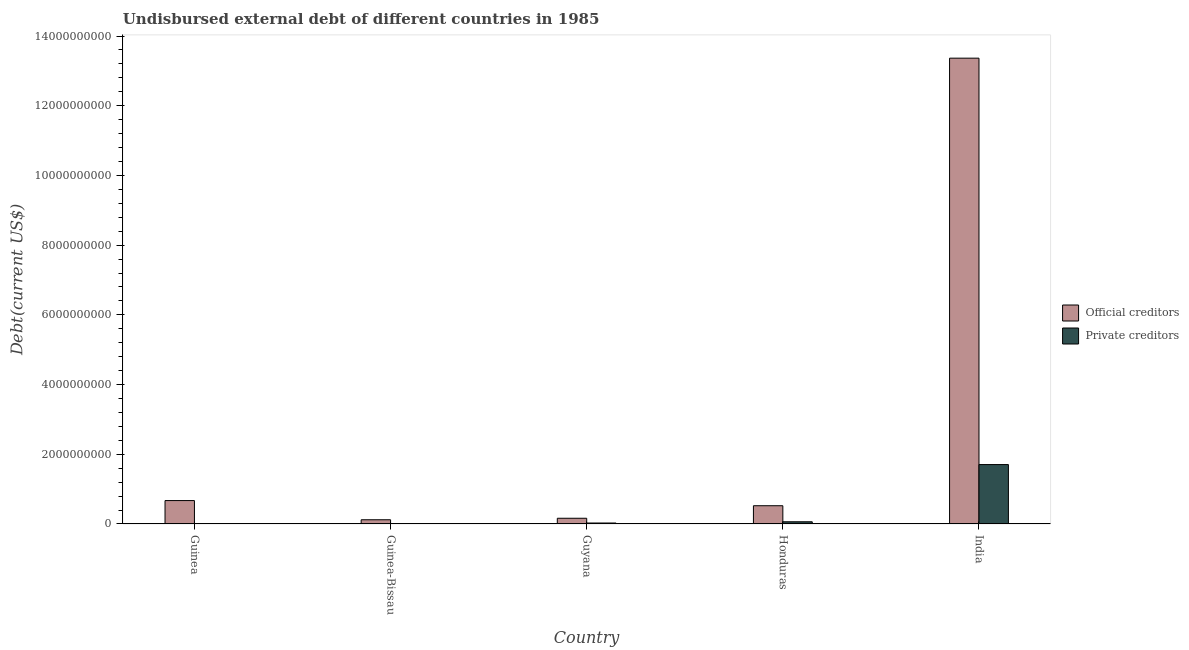How many different coloured bars are there?
Ensure brevity in your answer.  2. How many bars are there on the 2nd tick from the left?
Give a very brief answer. 2. How many bars are there on the 4th tick from the right?
Provide a succinct answer. 2. What is the label of the 5th group of bars from the left?
Give a very brief answer. India. What is the undisbursed external debt of official creditors in India?
Ensure brevity in your answer.  1.34e+1. Across all countries, what is the maximum undisbursed external debt of private creditors?
Offer a terse response. 1.70e+09. Across all countries, what is the minimum undisbursed external debt of private creditors?
Ensure brevity in your answer.  3.49e+06. In which country was the undisbursed external debt of official creditors minimum?
Your response must be concise. Guinea-Bissau. What is the total undisbursed external debt of official creditors in the graph?
Offer a very short reply. 1.48e+1. What is the difference between the undisbursed external debt of official creditors in Guinea and that in India?
Provide a short and direct response. -1.27e+1. What is the difference between the undisbursed external debt of official creditors in Guinea-Bissau and the undisbursed external debt of private creditors in India?
Ensure brevity in your answer.  -1.58e+09. What is the average undisbursed external debt of official creditors per country?
Your answer should be very brief. 2.97e+09. What is the difference between the undisbursed external debt of private creditors and undisbursed external debt of official creditors in Guyana?
Your response must be concise. -1.36e+08. What is the ratio of the undisbursed external debt of private creditors in Guinea to that in Guyana?
Ensure brevity in your answer.  0.13. Is the difference between the undisbursed external debt of private creditors in Guinea and India greater than the difference between the undisbursed external debt of official creditors in Guinea and India?
Provide a succinct answer. Yes. What is the difference between the highest and the second highest undisbursed external debt of private creditors?
Your answer should be very brief. 1.64e+09. What is the difference between the highest and the lowest undisbursed external debt of official creditors?
Your answer should be compact. 1.32e+1. In how many countries, is the undisbursed external debt of official creditors greater than the average undisbursed external debt of official creditors taken over all countries?
Ensure brevity in your answer.  1. Is the sum of the undisbursed external debt of private creditors in Guinea and India greater than the maximum undisbursed external debt of official creditors across all countries?
Give a very brief answer. No. What does the 1st bar from the left in Guinea represents?
Make the answer very short. Official creditors. What does the 2nd bar from the right in India represents?
Make the answer very short. Official creditors. Are all the bars in the graph horizontal?
Your answer should be compact. No. How many countries are there in the graph?
Provide a short and direct response. 5. What is the difference between two consecutive major ticks on the Y-axis?
Provide a short and direct response. 2.00e+09. Does the graph contain grids?
Your response must be concise. No. Where does the legend appear in the graph?
Provide a short and direct response. Center right. How are the legend labels stacked?
Make the answer very short. Vertical. What is the title of the graph?
Your response must be concise. Undisbursed external debt of different countries in 1985. Does "Domestic liabilities" appear as one of the legend labels in the graph?
Your response must be concise. No. What is the label or title of the X-axis?
Make the answer very short. Country. What is the label or title of the Y-axis?
Provide a short and direct response. Debt(current US$). What is the Debt(current US$) of Official creditors in Guinea?
Provide a succinct answer. 6.72e+08. What is the Debt(current US$) of Private creditors in Guinea?
Give a very brief answer. 3.49e+06. What is the Debt(current US$) in Official creditors in Guinea-Bissau?
Provide a succinct answer. 1.21e+08. What is the Debt(current US$) in Private creditors in Guinea-Bissau?
Give a very brief answer. 7.95e+06. What is the Debt(current US$) in Official creditors in Guyana?
Make the answer very short. 1.64e+08. What is the Debt(current US$) of Private creditors in Guyana?
Offer a terse response. 2.79e+07. What is the Debt(current US$) in Official creditors in Honduras?
Keep it short and to the point. 5.24e+08. What is the Debt(current US$) in Private creditors in Honduras?
Offer a very short reply. 6.33e+07. What is the Debt(current US$) in Official creditors in India?
Your response must be concise. 1.34e+1. What is the Debt(current US$) of Private creditors in India?
Offer a very short reply. 1.70e+09. Across all countries, what is the maximum Debt(current US$) in Official creditors?
Your answer should be compact. 1.34e+1. Across all countries, what is the maximum Debt(current US$) of Private creditors?
Your response must be concise. 1.70e+09. Across all countries, what is the minimum Debt(current US$) in Official creditors?
Make the answer very short. 1.21e+08. Across all countries, what is the minimum Debt(current US$) in Private creditors?
Your answer should be very brief. 3.49e+06. What is the total Debt(current US$) of Official creditors in the graph?
Your answer should be very brief. 1.48e+1. What is the total Debt(current US$) of Private creditors in the graph?
Give a very brief answer. 1.81e+09. What is the difference between the Debt(current US$) in Official creditors in Guinea and that in Guinea-Bissau?
Your response must be concise. 5.51e+08. What is the difference between the Debt(current US$) in Private creditors in Guinea and that in Guinea-Bissau?
Keep it short and to the point. -4.47e+06. What is the difference between the Debt(current US$) in Official creditors in Guinea and that in Guyana?
Offer a very short reply. 5.08e+08. What is the difference between the Debt(current US$) in Private creditors in Guinea and that in Guyana?
Provide a succinct answer. -2.44e+07. What is the difference between the Debt(current US$) of Official creditors in Guinea and that in Honduras?
Provide a succinct answer. 1.48e+08. What is the difference between the Debt(current US$) of Private creditors in Guinea and that in Honduras?
Provide a succinct answer. -5.99e+07. What is the difference between the Debt(current US$) of Official creditors in Guinea and that in India?
Provide a succinct answer. -1.27e+1. What is the difference between the Debt(current US$) in Private creditors in Guinea and that in India?
Your response must be concise. -1.70e+09. What is the difference between the Debt(current US$) of Official creditors in Guinea-Bissau and that in Guyana?
Offer a terse response. -4.32e+07. What is the difference between the Debt(current US$) of Private creditors in Guinea-Bissau and that in Guyana?
Provide a succinct answer. -1.99e+07. What is the difference between the Debt(current US$) of Official creditors in Guinea-Bissau and that in Honduras?
Give a very brief answer. -4.03e+08. What is the difference between the Debt(current US$) in Private creditors in Guinea-Bissau and that in Honduras?
Offer a terse response. -5.54e+07. What is the difference between the Debt(current US$) in Official creditors in Guinea-Bissau and that in India?
Give a very brief answer. -1.32e+1. What is the difference between the Debt(current US$) of Private creditors in Guinea-Bissau and that in India?
Your answer should be very brief. -1.70e+09. What is the difference between the Debt(current US$) in Official creditors in Guyana and that in Honduras?
Give a very brief answer. -3.59e+08. What is the difference between the Debt(current US$) of Private creditors in Guyana and that in Honduras?
Offer a terse response. -3.55e+07. What is the difference between the Debt(current US$) of Official creditors in Guyana and that in India?
Keep it short and to the point. -1.32e+1. What is the difference between the Debt(current US$) in Private creditors in Guyana and that in India?
Your answer should be very brief. -1.68e+09. What is the difference between the Debt(current US$) in Official creditors in Honduras and that in India?
Your response must be concise. -1.28e+1. What is the difference between the Debt(current US$) of Private creditors in Honduras and that in India?
Ensure brevity in your answer.  -1.64e+09. What is the difference between the Debt(current US$) of Official creditors in Guinea and the Debt(current US$) of Private creditors in Guinea-Bissau?
Your answer should be compact. 6.64e+08. What is the difference between the Debt(current US$) in Official creditors in Guinea and the Debt(current US$) in Private creditors in Guyana?
Your answer should be compact. 6.44e+08. What is the difference between the Debt(current US$) of Official creditors in Guinea and the Debt(current US$) of Private creditors in Honduras?
Offer a terse response. 6.08e+08. What is the difference between the Debt(current US$) of Official creditors in Guinea and the Debt(current US$) of Private creditors in India?
Give a very brief answer. -1.03e+09. What is the difference between the Debt(current US$) of Official creditors in Guinea-Bissau and the Debt(current US$) of Private creditors in Guyana?
Your answer should be compact. 9.31e+07. What is the difference between the Debt(current US$) of Official creditors in Guinea-Bissau and the Debt(current US$) of Private creditors in Honduras?
Make the answer very short. 5.76e+07. What is the difference between the Debt(current US$) in Official creditors in Guinea-Bissau and the Debt(current US$) in Private creditors in India?
Make the answer very short. -1.58e+09. What is the difference between the Debt(current US$) in Official creditors in Guyana and the Debt(current US$) in Private creditors in Honduras?
Give a very brief answer. 1.01e+08. What is the difference between the Debt(current US$) of Official creditors in Guyana and the Debt(current US$) of Private creditors in India?
Provide a succinct answer. -1.54e+09. What is the difference between the Debt(current US$) in Official creditors in Honduras and the Debt(current US$) in Private creditors in India?
Ensure brevity in your answer.  -1.18e+09. What is the average Debt(current US$) in Official creditors per country?
Your answer should be very brief. 2.97e+09. What is the average Debt(current US$) of Private creditors per country?
Keep it short and to the point. 3.61e+08. What is the difference between the Debt(current US$) in Official creditors and Debt(current US$) in Private creditors in Guinea?
Provide a short and direct response. 6.68e+08. What is the difference between the Debt(current US$) of Official creditors and Debt(current US$) of Private creditors in Guinea-Bissau?
Offer a very short reply. 1.13e+08. What is the difference between the Debt(current US$) of Official creditors and Debt(current US$) of Private creditors in Guyana?
Provide a short and direct response. 1.36e+08. What is the difference between the Debt(current US$) of Official creditors and Debt(current US$) of Private creditors in Honduras?
Offer a very short reply. 4.60e+08. What is the difference between the Debt(current US$) in Official creditors and Debt(current US$) in Private creditors in India?
Provide a short and direct response. 1.17e+1. What is the ratio of the Debt(current US$) of Official creditors in Guinea to that in Guinea-Bissau?
Give a very brief answer. 5.55. What is the ratio of the Debt(current US$) in Private creditors in Guinea to that in Guinea-Bissau?
Your answer should be compact. 0.44. What is the ratio of the Debt(current US$) in Official creditors in Guinea to that in Guyana?
Your response must be concise. 4.09. What is the ratio of the Debt(current US$) of Private creditors in Guinea to that in Guyana?
Ensure brevity in your answer.  0.13. What is the ratio of the Debt(current US$) in Official creditors in Guinea to that in Honduras?
Offer a very short reply. 1.28. What is the ratio of the Debt(current US$) of Private creditors in Guinea to that in Honduras?
Ensure brevity in your answer.  0.06. What is the ratio of the Debt(current US$) of Official creditors in Guinea to that in India?
Provide a short and direct response. 0.05. What is the ratio of the Debt(current US$) in Private creditors in Guinea to that in India?
Offer a terse response. 0. What is the ratio of the Debt(current US$) in Official creditors in Guinea-Bissau to that in Guyana?
Give a very brief answer. 0.74. What is the ratio of the Debt(current US$) of Private creditors in Guinea-Bissau to that in Guyana?
Give a very brief answer. 0.29. What is the ratio of the Debt(current US$) of Official creditors in Guinea-Bissau to that in Honduras?
Offer a terse response. 0.23. What is the ratio of the Debt(current US$) in Private creditors in Guinea-Bissau to that in Honduras?
Offer a very short reply. 0.13. What is the ratio of the Debt(current US$) of Official creditors in Guinea-Bissau to that in India?
Provide a succinct answer. 0.01. What is the ratio of the Debt(current US$) in Private creditors in Guinea-Bissau to that in India?
Your answer should be very brief. 0. What is the ratio of the Debt(current US$) in Official creditors in Guyana to that in Honduras?
Your response must be concise. 0.31. What is the ratio of the Debt(current US$) in Private creditors in Guyana to that in Honduras?
Offer a terse response. 0.44. What is the ratio of the Debt(current US$) in Official creditors in Guyana to that in India?
Provide a short and direct response. 0.01. What is the ratio of the Debt(current US$) in Private creditors in Guyana to that in India?
Provide a succinct answer. 0.02. What is the ratio of the Debt(current US$) in Official creditors in Honduras to that in India?
Provide a short and direct response. 0.04. What is the ratio of the Debt(current US$) of Private creditors in Honduras to that in India?
Give a very brief answer. 0.04. What is the difference between the highest and the second highest Debt(current US$) in Official creditors?
Your response must be concise. 1.27e+1. What is the difference between the highest and the second highest Debt(current US$) in Private creditors?
Offer a terse response. 1.64e+09. What is the difference between the highest and the lowest Debt(current US$) in Official creditors?
Provide a succinct answer. 1.32e+1. What is the difference between the highest and the lowest Debt(current US$) in Private creditors?
Your response must be concise. 1.70e+09. 